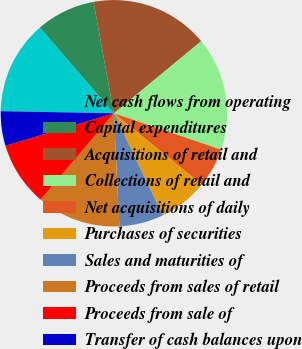Convert chart to OTSL. <chart><loc_0><loc_0><loc_500><loc_500><pie_chart><fcel>Net cash flows from operating<fcel>Capital expenditures<fcel>Acquisitions of retail and<fcel>Collections of retail and<fcel>Net acquisitions of daily<fcel>Purchases of securities<fcel>Sales and maturities of<fcel>Proceeds from sales of retail<fcel>Proceeds from sale of<fcel>Transfer of cash balances upon<nl><fcel>13.38%<fcel>8.45%<fcel>16.9%<fcel>16.19%<fcel>5.64%<fcel>7.04%<fcel>6.34%<fcel>11.97%<fcel>9.16%<fcel>4.93%<nl></chart> 